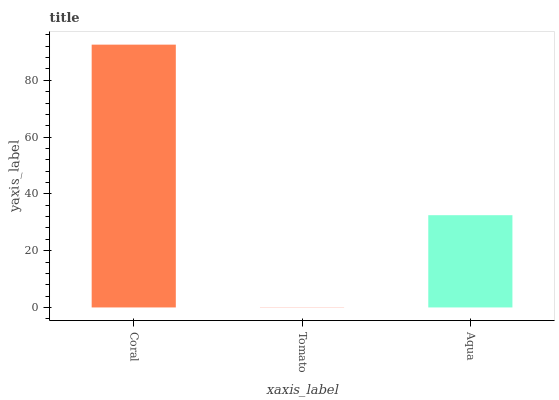Is Tomato the minimum?
Answer yes or no. Yes. Is Coral the maximum?
Answer yes or no. Yes. Is Aqua the minimum?
Answer yes or no. No. Is Aqua the maximum?
Answer yes or no. No. Is Aqua greater than Tomato?
Answer yes or no. Yes. Is Tomato less than Aqua?
Answer yes or no. Yes. Is Tomato greater than Aqua?
Answer yes or no. No. Is Aqua less than Tomato?
Answer yes or no. No. Is Aqua the high median?
Answer yes or no. Yes. Is Aqua the low median?
Answer yes or no. Yes. Is Tomato the high median?
Answer yes or no. No. Is Coral the low median?
Answer yes or no. No. 